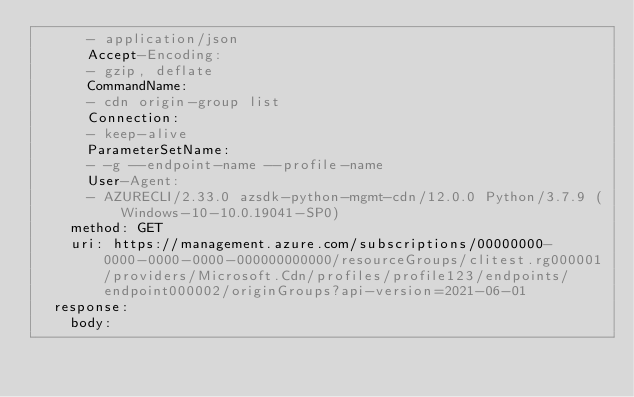Convert code to text. <code><loc_0><loc_0><loc_500><loc_500><_YAML_>      - application/json
      Accept-Encoding:
      - gzip, deflate
      CommandName:
      - cdn origin-group list
      Connection:
      - keep-alive
      ParameterSetName:
      - -g --endpoint-name --profile-name
      User-Agent:
      - AZURECLI/2.33.0 azsdk-python-mgmt-cdn/12.0.0 Python/3.7.9 (Windows-10-10.0.19041-SP0)
    method: GET
    uri: https://management.azure.com/subscriptions/00000000-0000-0000-0000-000000000000/resourceGroups/clitest.rg000001/providers/Microsoft.Cdn/profiles/profile123/endpoints/endpoint000002/originGroups?api-version=2021-06-01
  response:
    body:</code> 